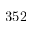Convert formula to latex. <formula><loc_0><loc_0><loc_500><loc_500>3 5 2</formula> 